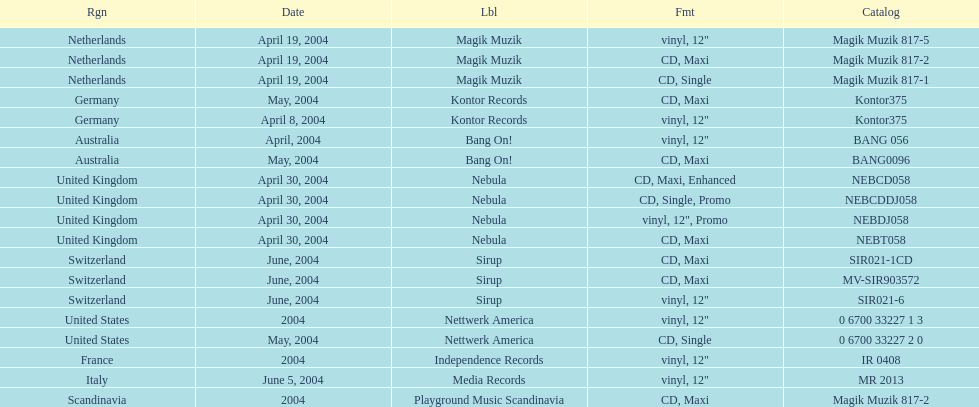What area was included in the sir021-1cd catalogue? Switzerland. 